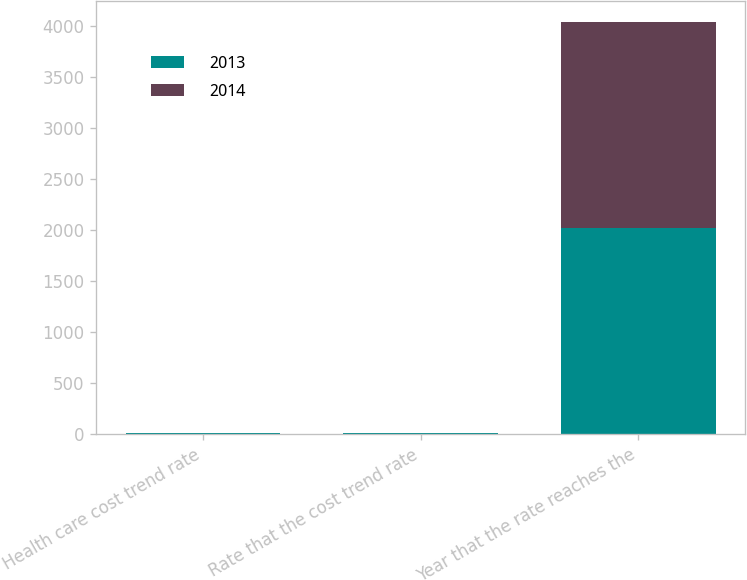Convert chart. <chart><loc_0><loc_0><loc_500><loc_500><stacked_bar_chart><ecel><fcel>Health care cost trend rate<fcel>Rate that the cost trend rate<fcel>Year that the rate reaches the<nl><fcel>2013<fcel>7<fcel>5<fcel>2022<nl><fcel>2014<fcel>7<fcel>5<fcel>2017<nl></chart> 